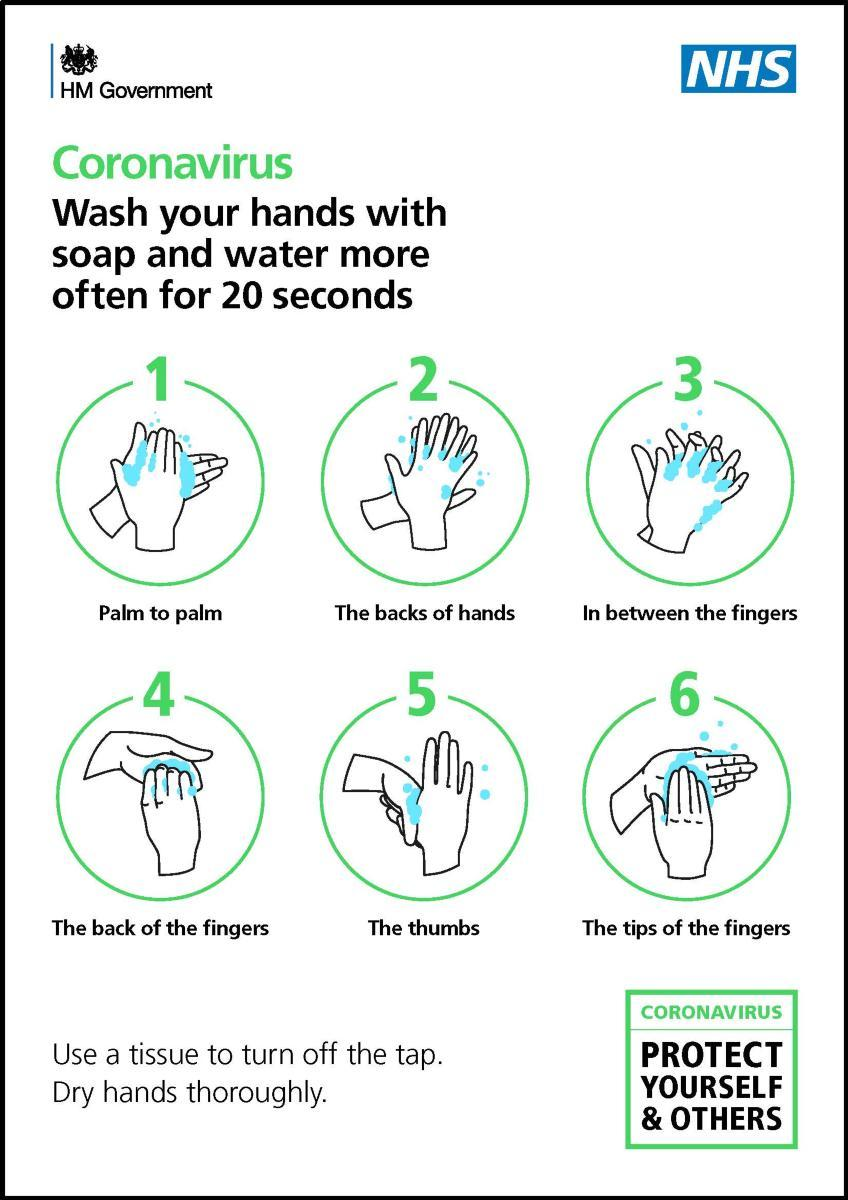List a handful of essential elements in this visual. The infographic image shows six different ways of washing hands. 